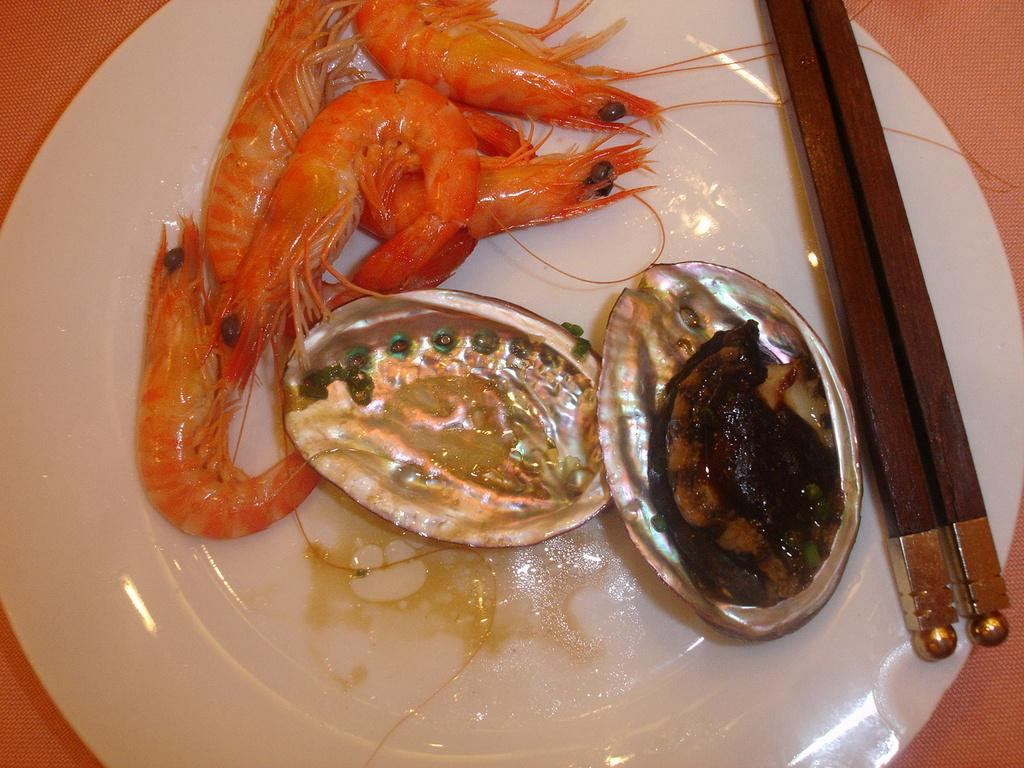What is on the plate in the image? There are food items in the plate. What utensil is present in the image? Chopsticks are visible in the image. What is the distance between the food items and the action in the image? There is no action or distance mentioned in the image; it only shows a plate with food items and chopsticks. 